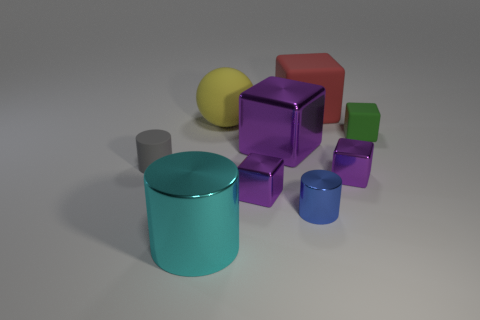How many purple blocks must be subtracted to get 1 purple blocks? 2 Subtract all cyan balls. How many purple cubes are left? 3 Subtract all red cubes. How many cubes are left? 4 Subtract all big purple shiny blocks. How many blocks are left? 4 Subtract 2 blocks. How many blocks are left? 3 Subtract all cyan cubes. Subtract all gray spheres. How many cubes are left? 5 Add 1 cyan cylinders. How many objects exist? 10 Subtract all cylinders. How many objects are left? 6 Add 6 big purple cubes. How many big purple cubes exist? 7 Subtract 0 purple cylinders. How many objects are left? 9 